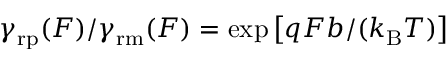Convert formula to latex. <formula><loc_0><loc_0><loc_500><loc_500>\gamma _ { r p } ( F ) / \gamma _ { r m } ( F ) = \exp \left [ q F b / ( k _ { B } T ) \right ]</formula> 